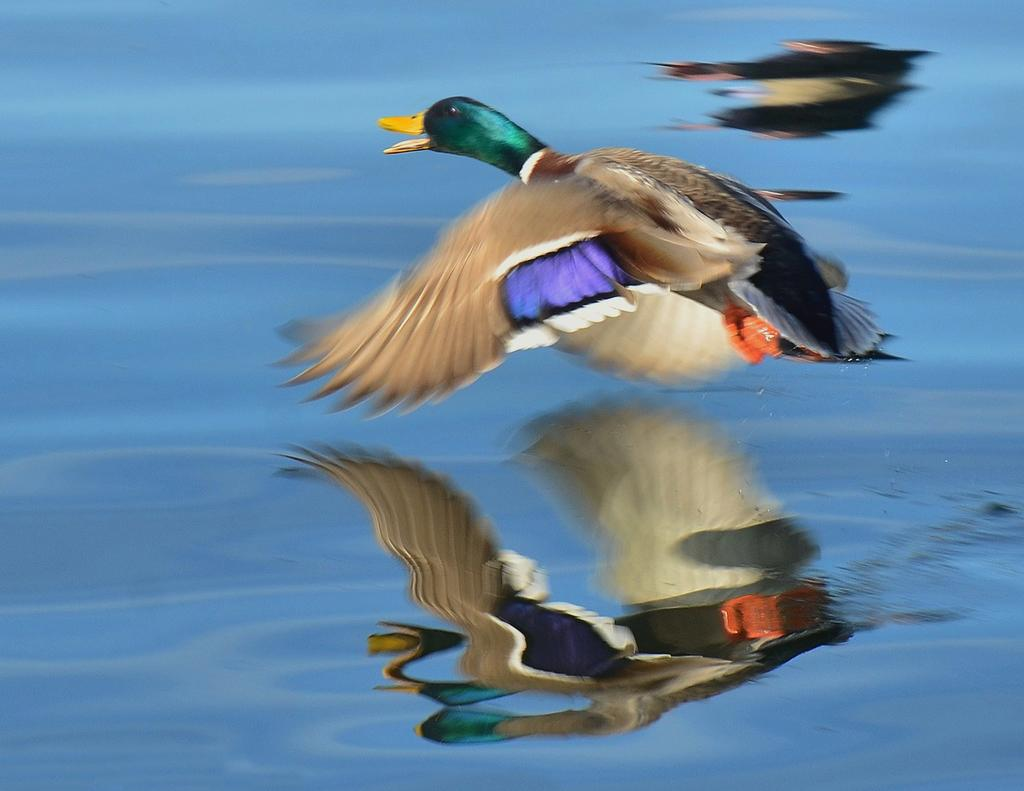What is the bird in the image doing? The bird is flying in the air. What can be seen in the background of the image? There is water visible in the image. What is the reflection of in the image? The reflection of a bird is present in the image. What type of root can be seen growing in the water in the image? There is no root visible in the image; it only features a bird flying in the air and its reflection in the water. 